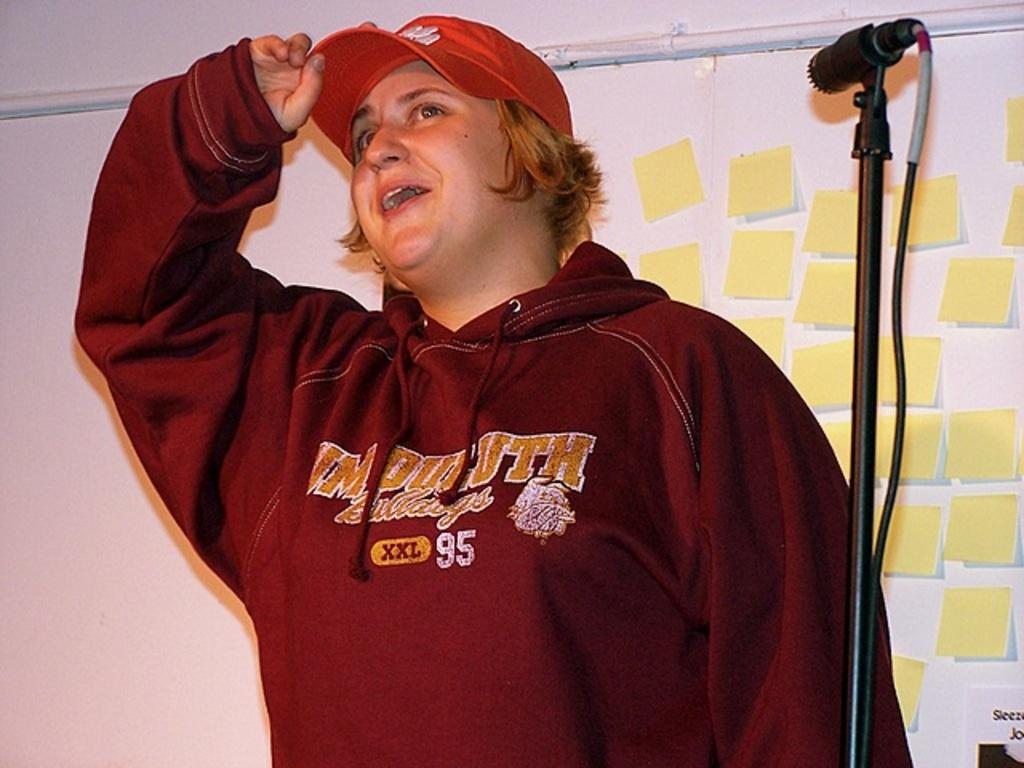What is the main subject of the image? There is a person in the image. Can you describe the person's attire? The person is wearing a cap. What can be seen near the person in the image? The person is standing near a mike stand. What is visible in the background of the image? There are papers attached to the wall in the background. What type of bucket can be seen hanging from the wall in the image? There is no bucket present in the image; only papers are attached to the wall in the background. What type of frame is holding the earth in the image? There is no frame or earth present in the image. 